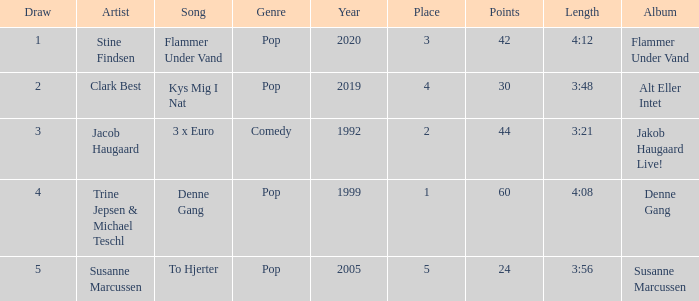What is the lowest Draw when the Artist is Stine Findsen and the Points are larger than 42? None. 